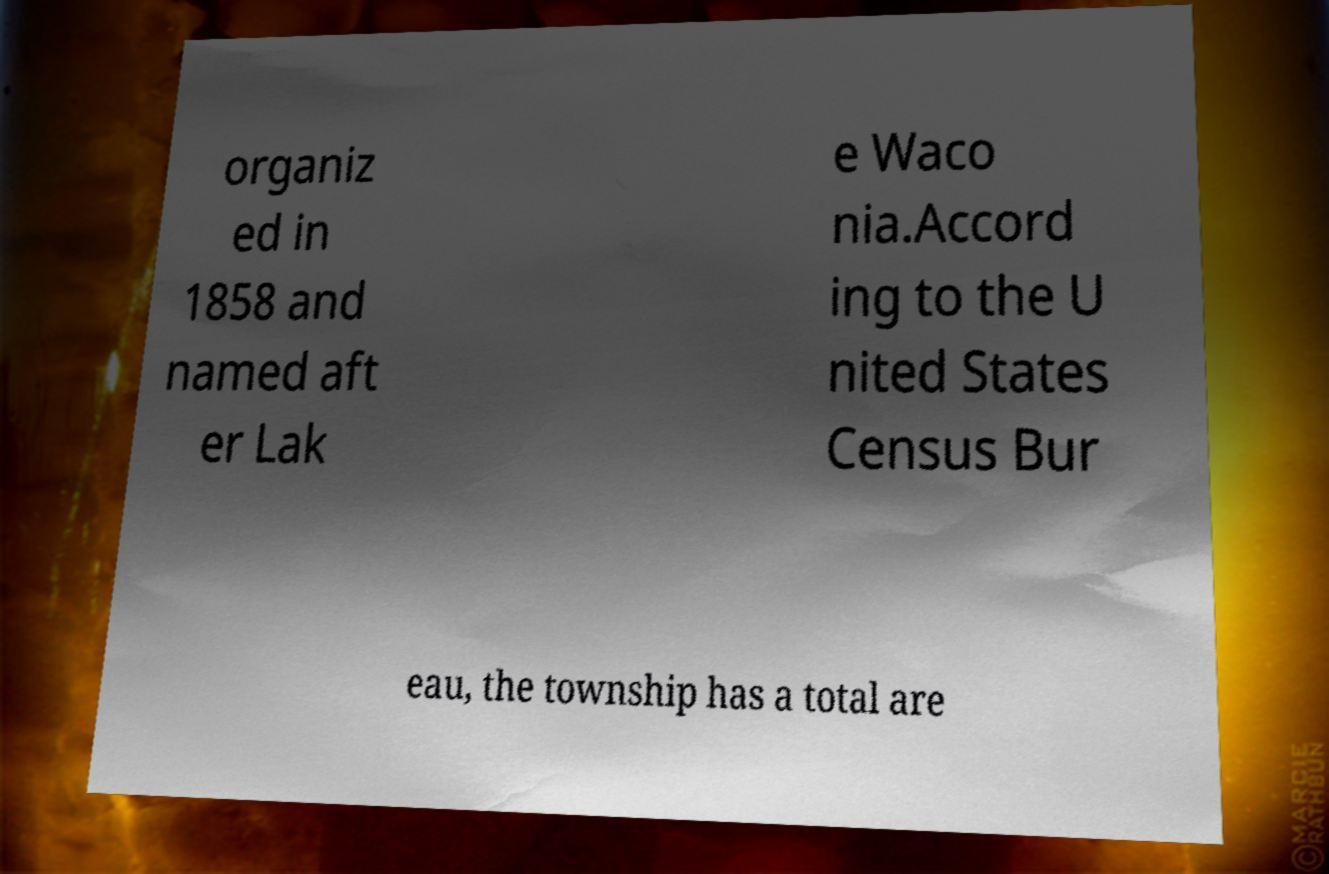Can you accurately transcribe the text from the provided image for me? organiz ed in 1858 and named aft er Lak e Waco nia.Accord ing to the U nited States Census Bur eau, the township has a total are 